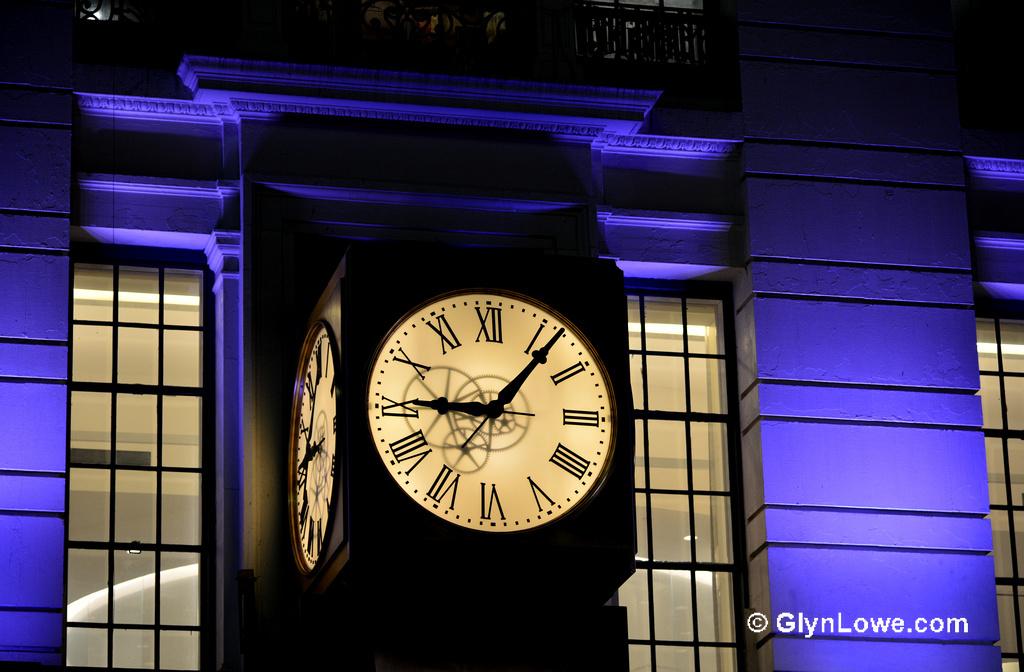What is the domain name shown on the image?
Ensure brevity in your answer.  Glynlowe.com. Whats the time on the clock?
Ensure brevity in your answer.  9:06. 